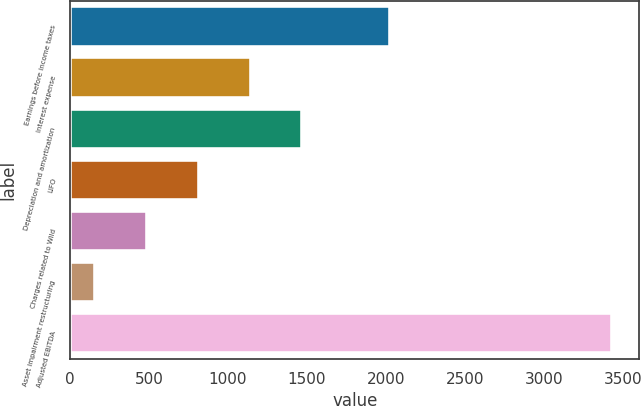<chart> <loc_0><loc_0><loc_500><loc_500><bar_chart><fcel>Earnings before income taxes<fcel>Interest expense<fcel>Depreciation and amortization<fcel>LIFO<fcel>Charges related to Wild<fcel>Asset impairment restructuring<fcel>Adjusted EBITDA<nl><fcel>2024<fcel>1142.6<fcel>1469.8<fcel>815.4<fcel>488.2<fcel>161<fcel>3433<nl></chart> 